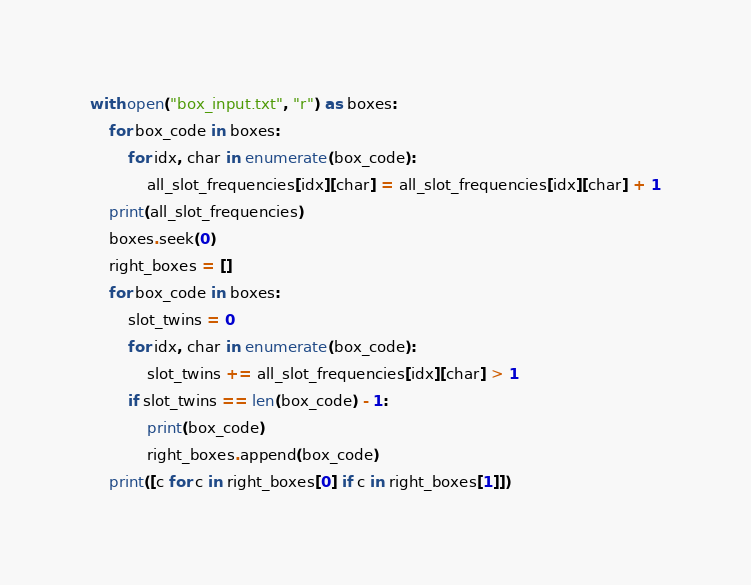<code> <loc_0><loc_0><loc_500><loc_500><_Python_>with open("box_input.txt", "r") as boxes:
    for box_code in boxes:
        for idx, char in enumerate(box_code):
            all_slot_frequencies[idx][char] = all_slot_frequencies[idx][char] + 1
    print(all_slot_frequencies)
    boxes.seek(0)
    right_boxes = []
    for box_code in boxes:
        slot_twins = 0
        for idx, char in enumerate(box_code):
            slot_twins += all_slot_frequencies[idx][char] > 1
        if slot_twins == len(box_code) - 1:
            print(box_code)
            right_boxes.append(box_code)
    print([c for c in right_boxes[0] if c in right_boxes[1]])</code> 